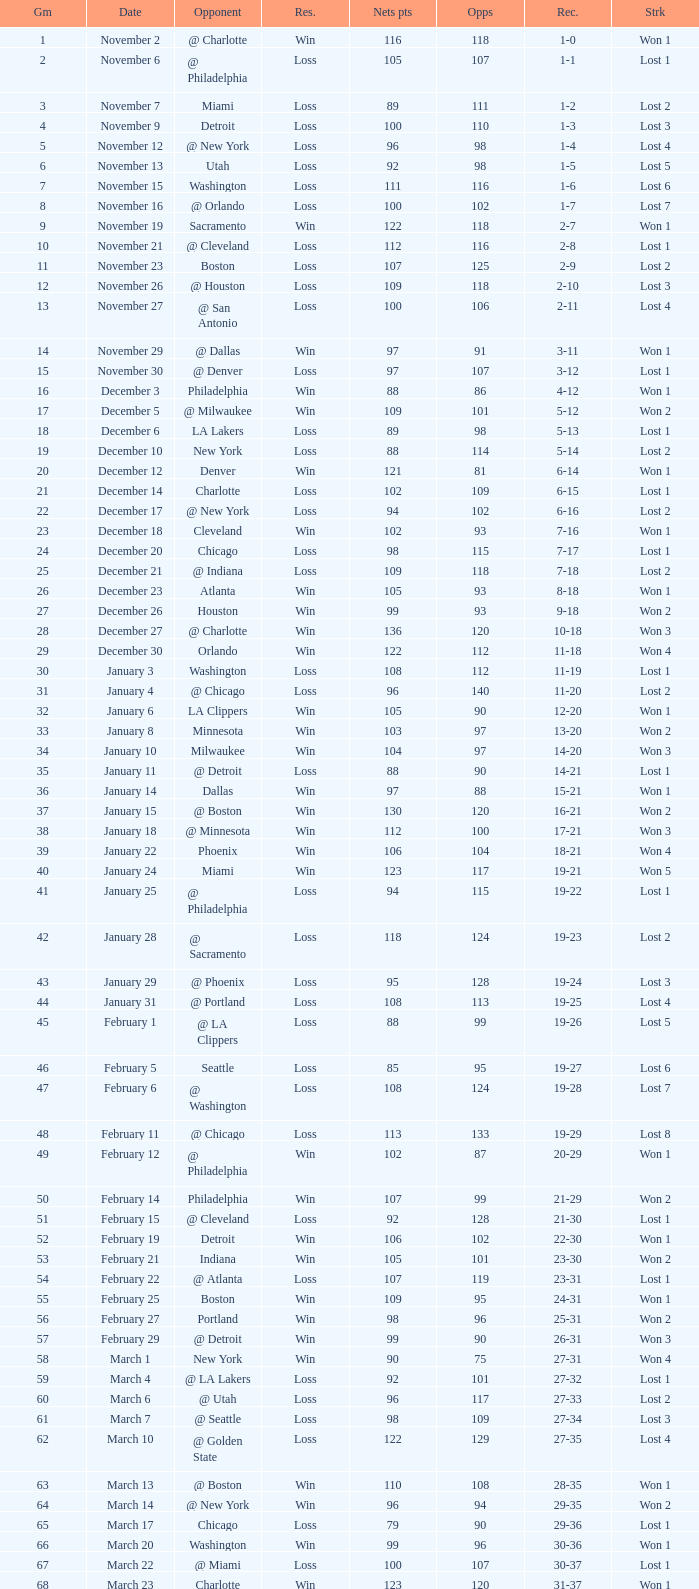How many games had fewer than 118 opponents and more than 109 net points with an opponent of Washington? 1.0. 